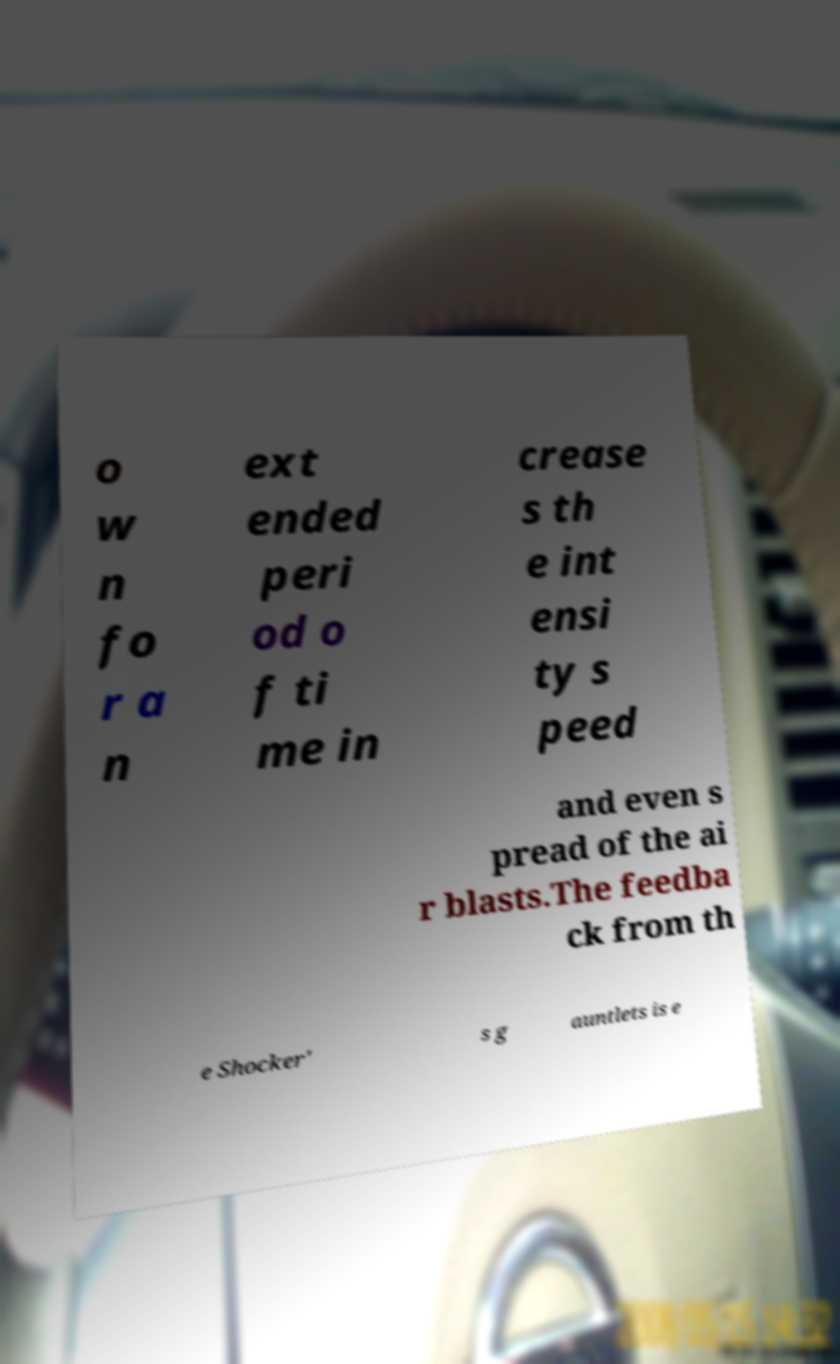Please identify and transcribe the text found in this image. o w n fo r a n ext ended peri od o f ti me in crease s th e int ensi ty s peed and even s pread of the ai r blasts.The feedba ck from th e Shocker' s g auntlets is e 